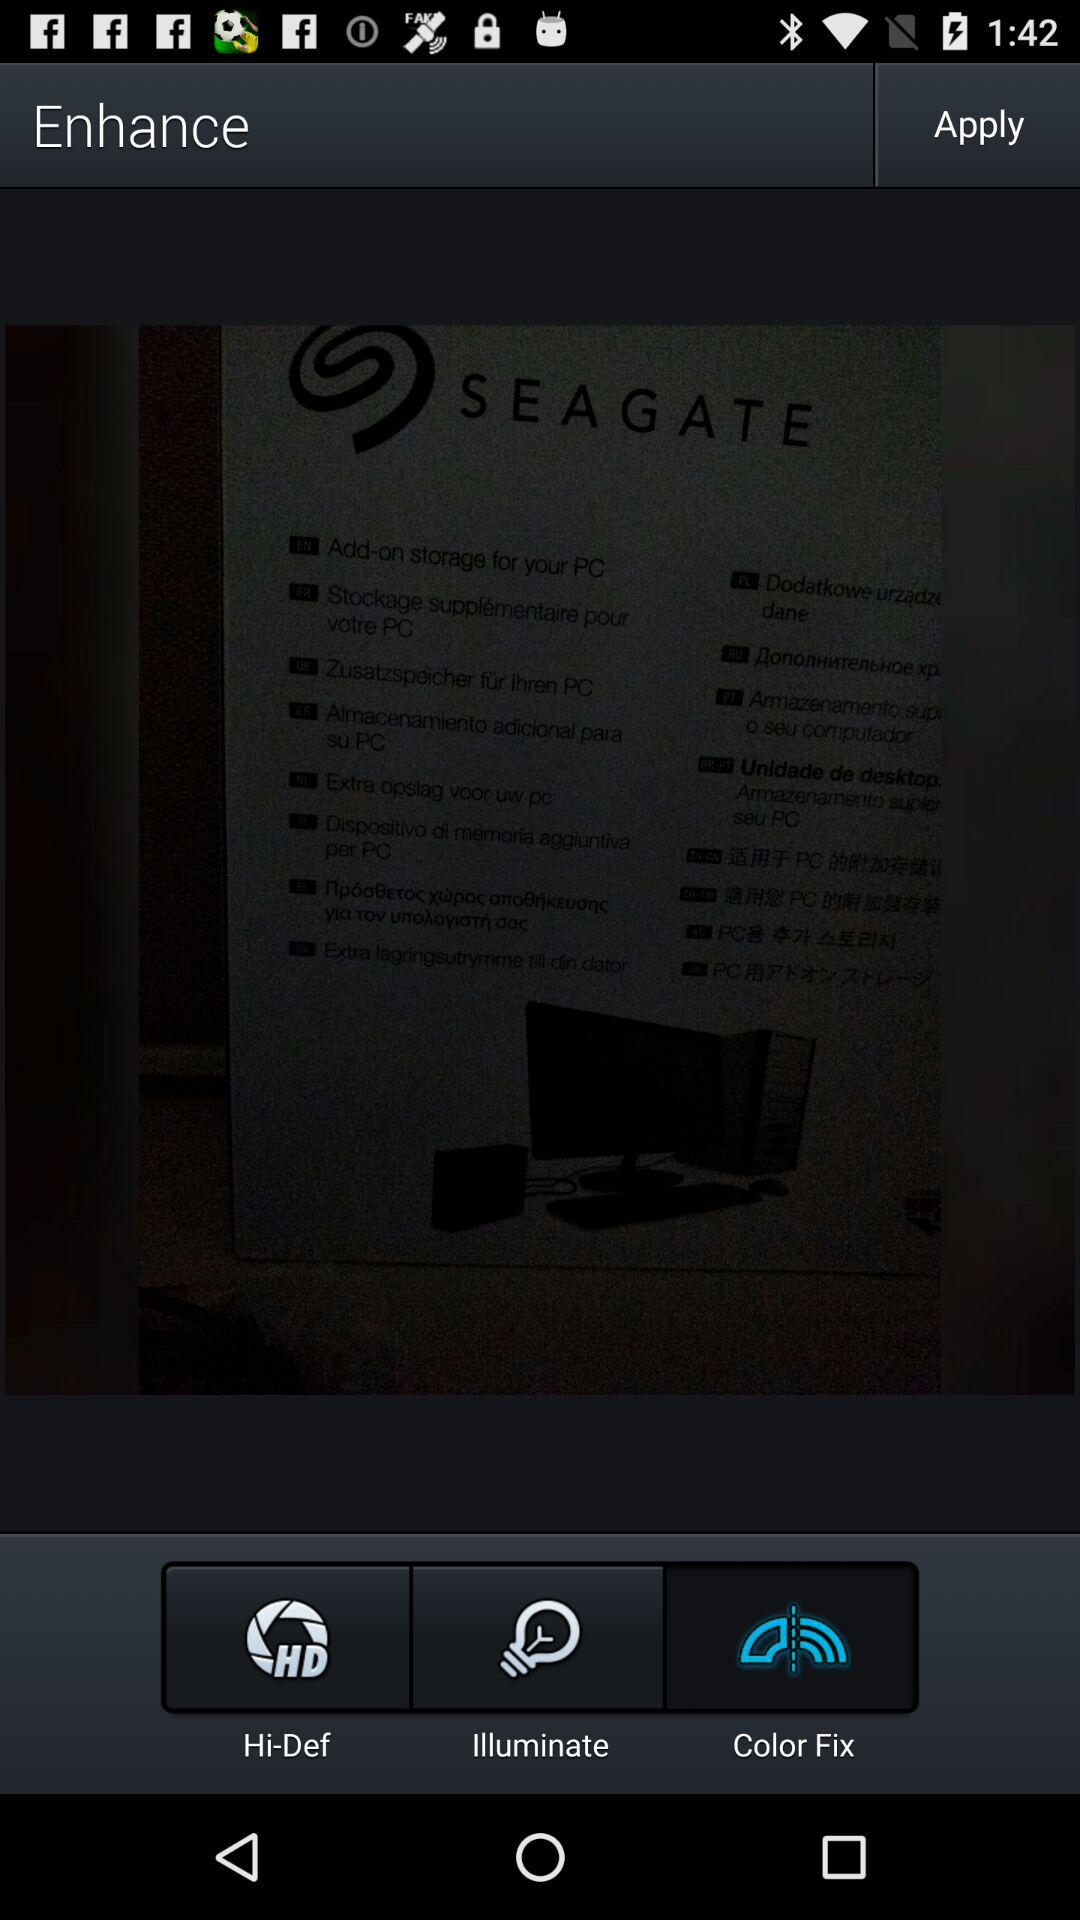What is the selected tab? The selected tab is "Color Fix". 